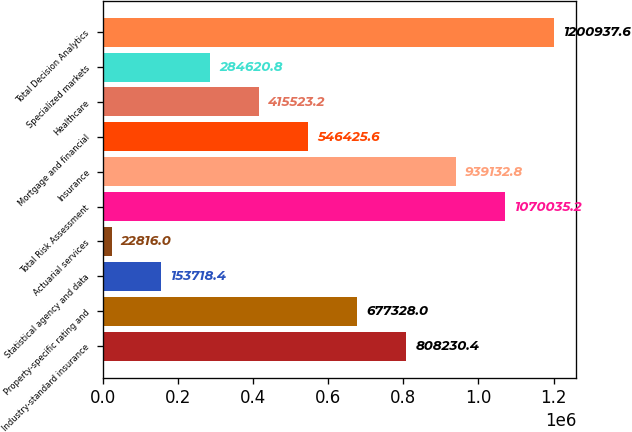Convert chart. <chart><loc_0><loc_0><loc_500><loc_500><bar_chart><fcel>Industry-standard insurance<fcel>Property-specific rating and<fcel>Statistical agency and data<fcel>Actuarial services<fcel>Total Risk Assessment<fcel>Insurance<fcel>Mortgage and financial<fcel>Healthcare<fcel>Specialized markets<fcel>Total Decision Analytics<nl><fcel>808230<fcel>677328<fcel>153718<fcel>22816<fcel>1.07004e+06<fcel>939133<fcel>546426<fcel>415523<fcel>284621<fcel>1.20094e+06<nl></chart> 